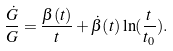Convert formula to latex. <formula><loc_0><loc_0><loc_500><loc_500>\frac { \dot { G } } { G } = \frac { \beta ( t ) } { t } + { \dot { \beta } } ( t ) \ln ( \frac { t } { t _ { 0 } } ) .</formula> 